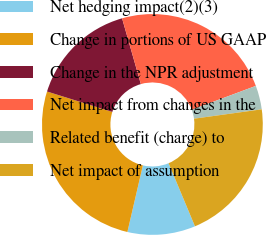Convert chart to OTSL. <chart><loc_0><loc_0><loc_500><loc_500><pie_chart><fcel>Net hedging impact(2)(3)<fcel>Change in portions of US GAAP<fcel>Change in the NPR adjustment<fcel>Net impact from changes in the<fcel>Related benefit (charge) to<fcel>Net impact of assumption<nl><fcel>9.94%<fcel>26.19%<fcel>15.75%<fcel>23.75%<fcel>3.49%<fcel>20.89%<nl></chart> 